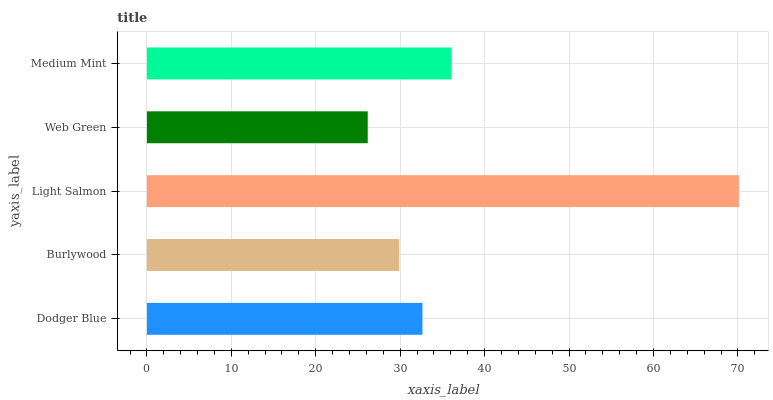Is Web Green the minimum?
Answer yes or no. Yes. Is Light Salmon the maximum?
Answer yes or no. Yes. Is Burlywood the minimum?
Answer yes or no. No. Is Burlywood the maximum?
Answer yes or no. No. Is Dodger Blue greater than Burlywood?
Answer yes or no. Yes. Is Burlywood less than Dodger Blue?
Answer yes or no. Yes. Is Burlywood greater than Dodger Blue?
Answer yes or no. No. Is Dodger Blue less than Burlywood?
Answer yes or no. No. Is Dodger Blue the high median?
Answer yes or no. Yes. Is Dodger Blue the low median?
Answer yes or no. Yes. Is Light Salmon the high median?
Answer yes or no. No. Is Web Green the low median?
Answer yes or no. No. 